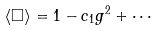<formula> <loc_0><loc_0><loc_500><loc_500>\langle \Box \rangle = 1 - c _ { 1 } g ^ { 2 } + \cdots</formula> 